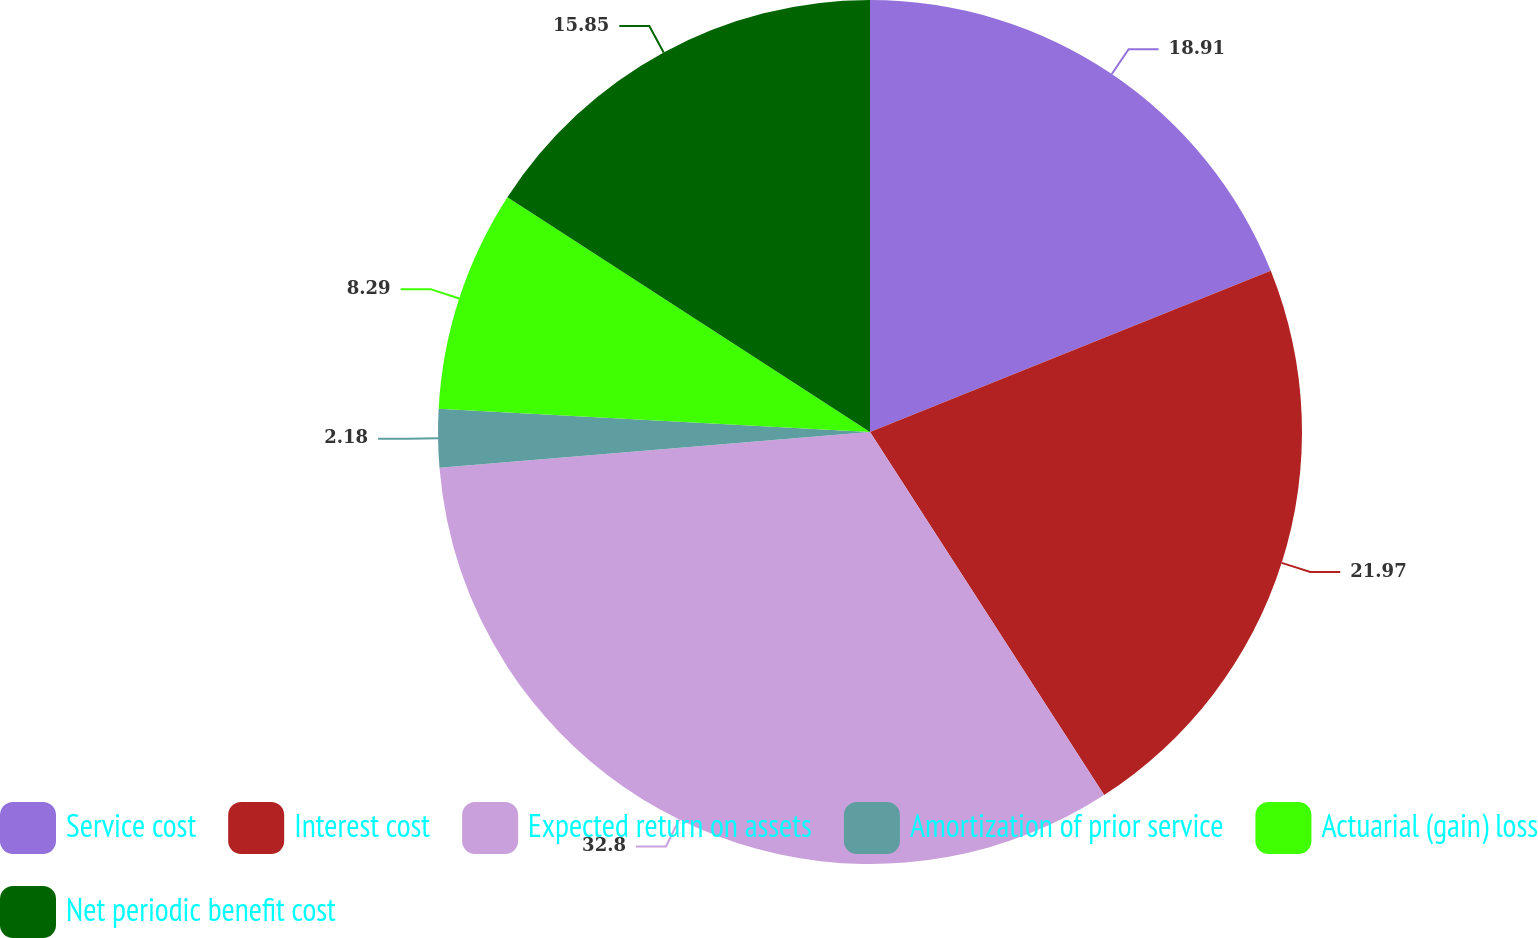Convert chart to OTSL. <chart><loc_0><loc_0><loc_500><loc_500><pie_chart><fcel>Service cost<fcel>Interest cost<fcel>Expected return on assets<fcel>Amortization of prior service<fcel>Actuarial (gain) loss<fcel>Net periodic benefit cost<nl><fcel>18.91%<fcel>21.97%<fcel>32.79%<fcel>2.18%<fcel>8.29%<fcel>15.85%<nl></chart> 